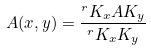Convert formula to latex. <formula><loc_0><loc_0><loc_500><loc_500>A ( x , y ) = \frac { ^ { r } { K _ { x } } { A K _ { y } } } { ^ { r } { K _ { x } } { K _ { y } } }</formula> 